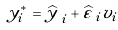Convert formula to latex. <formula><loc_0><loc_0><loc_500><loc_500>y _ { i } ^ { * } = { \widehat { y \, } } _ { i } + { \widehat { \varepsilon \, } } _ { i } v _ { i }</formula> 